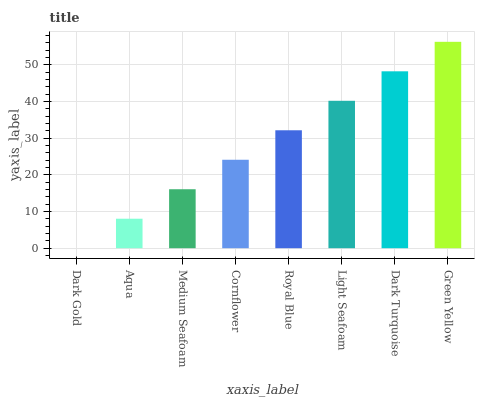Is Aqua the minimum?
Answer yes or no. No. Is Aqua the maximum?
Answer yes or no. No. Is Aqua greater than Dark Gold?
Answer yes or no. Yes. Is Dark Gold less than Aqua?
Answer yes or no. Yes. Is Dark Gold greater than Aqua?
Answer yes or no. No. Is Aqua less than Dark Gold?
Answer yes or no. No. Is Royal Blue the high median?
Answer yes or no. Yes. Is Cornflower the low median?
Answer yes or no. Yes. Is Green Yellow the high median?
Answer yes or no. No. Is Dark Turquoise the low median?
Answer yes or no. No. 